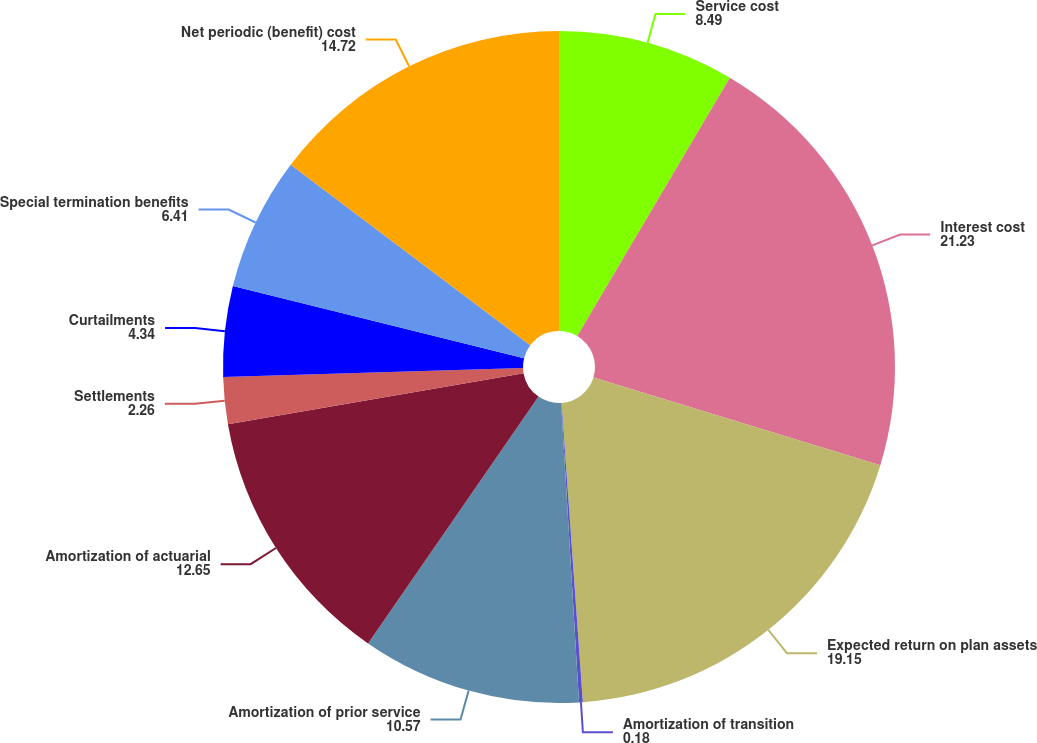<chart> <loc_0><loc_0><loc_500><loc_500><pie_chart><fcel>Service cost<fcel>Interest cost<fcel>Expected return on plan assets<fcel>Amortization of transition<fcel>Amortization of prior service<fcel>Amortization of actuarial<fcel>Settlements<fcel>Curtailments<fcel>Special termination benefits<fcel>Net periodic (benefit) cost<nl><fcel>8.49%<fcel>21.23%<fcel>19.15%<fcel>0.18%<fcel>10.57%<fcel>12.65%<fcel>2.26%<fcel>4.34%<fcel>6.41%<fcel>14.72%<nl></chart> 